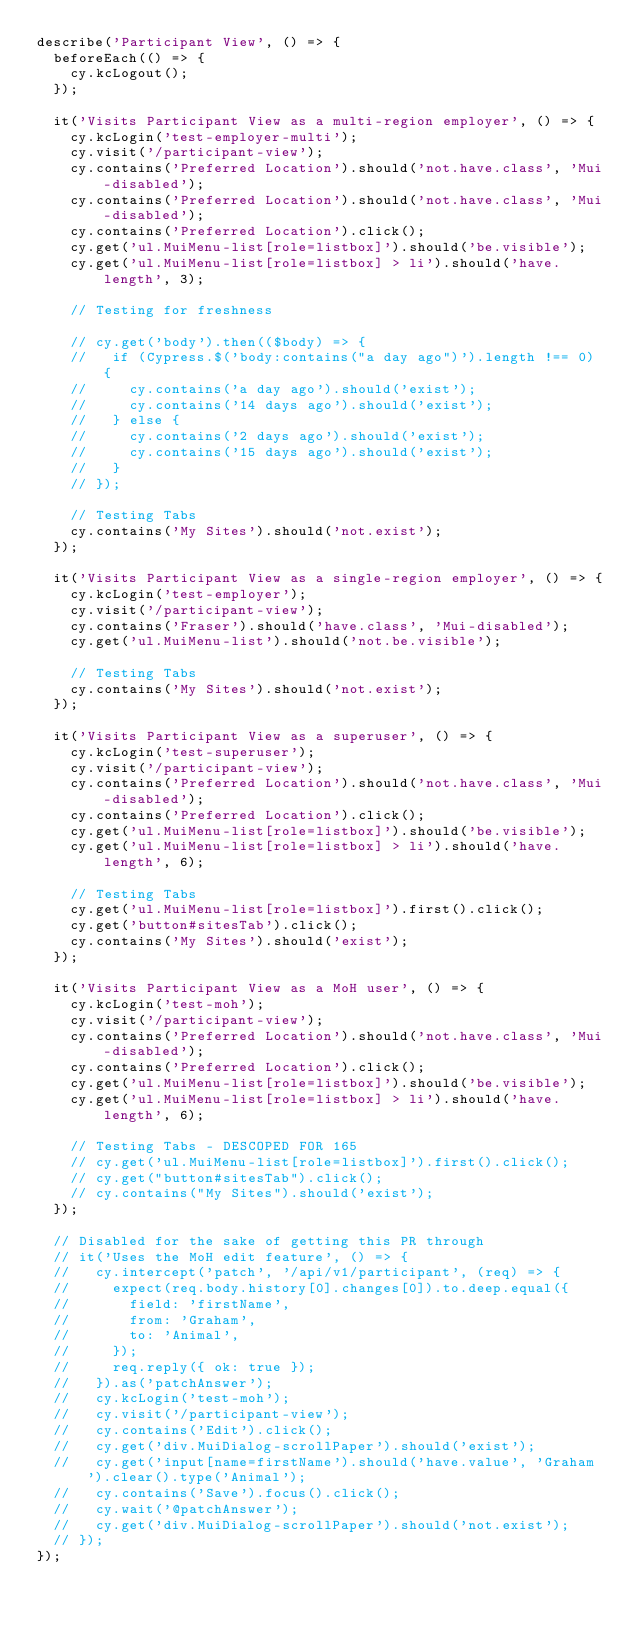<code> <loc_0><loc_0><loc_500><loc_500><_JavaScript_>describe('Participant View', () => {
  beforeEach(() => {
    cy.kcLogout();
  });

  it('Visits Participant View as a multi-region employer', () => {
    cy.kcLogin('test-employer-multi');
    cy.visit('/participant-view');
    cy.contains('Preferred Location').should('not.have.class', 'Mui-disabled');
    cy.contains('Preferred Location').should('not.have.class', 'Mui-disabled');
    cy.contains('Preferred Location').click();
    cy.get('ul.MuiMenu-list[role=listbox]').should('be.visible');
    cy.get('ul.MuiMenu-list[role=listbox] > li').should('have.length', 3);

    // Testing for freshness

    // cy.get('body').then(($body) => {
    //   if (Cypress.$('body:contains("a day ago")').length !== 0) {
    //     cy.contains('a day ago').should('exist');
    //     cy.contains('14 days ago').should('exist');
    //   } else {
    //     cy.contains('2 days ago').should('exist');
    //     cy.contains('15 days ago').should('exist');
    //   }
    // });

    // Testing Tabs
    cy.contains('My Sites').should('not.exist');
  });

  it('Visits Participant View as a single-region employer', () => {
    cy.kcLogin('test-employer');
    cy.visit('/participant-view');
    cy.contains('Fraser').should('have.class', 'Mui-disabled');
    cy.get('ul.MuiMenu-list').should('not.be.visible');

    // Testing Tabs
    cy.contains('My Sites').should('not.exist');
  });

  it('Visits Participant View as a superuser', () => {
    cy.kcLogin('test-superuser');
    cy.visit('/participant-view');
    cy.contains('Preferred Location').should('not.have.class', 'Mui-disabled');
    cy.contains('Preferred Location').click();
    cy.get('ul.MuiMenu-list[role=listbox]').should('be.visible');
    cy.get('ul.MuiMenu-list[role=listbox] > li').should('have.length', 6);

    // Testing Tabs
    cy.get('ul.MuiMenu-list[role=listbox]').first().click();
    cy.get('button#sitesTab').click();
    cy.contains('My Sites').should('exist');
  });

  it('Visits Participant View as a MoH user', () => {
    cy.kcLogin('test-moh');
    cy.visit('/participant-view');
    cy.contains('Preferred Location').should('not.have.class', 'Mui-disabled');
    cy.contains('Preferred Location').click();
    cy.get('ul.MuiMenu-list[role=listbox]').should('be.visible');
    cy.get('ul.MuiMenu-list[role=listbox] > li').should('have.length', 6);

    // Testing Tabs - DESCOPED FOR 165
    // cy.get('ul.MuiMenu-list[role=listbox]').first().click();
    // cy.get("button#sitesTab").click();
    // cy.contains("My Sites").should('exist');
  });

  // Disabled for the sake of getting this PR through
  // it('Uses the MoH edit feature', () => {
  //   cy.intercept('patch', '/api/v1/participant', (req) => {
  //     expect(req.body.history[0].changes[0]).to.deep.equal({
  //       field: 'firstName',
  //       from: 'Graham',
  //       to: 'Animal',
  //     });
  //     req.reply({ ok: true });
  //   }).as('patchAnswer');
  //   cy.kcLogin('test-moh');
  //   cy.visit('/participant-view');
  //   cy.contains('Edit').click();
  //   cy.get('div.MuiDialog-scrollPaper').should('exist');
  //   cy.get('input[name=firstName').should('have.value', 'Graham').clear().type('Animal');
  //   cy.contains('Save').focus().click();
  //   cy.wait('@patchAnswer');
  //   cy.get('div.MuiDialog-scrollPaper').should('not.exist');
  // });
});
</code> 